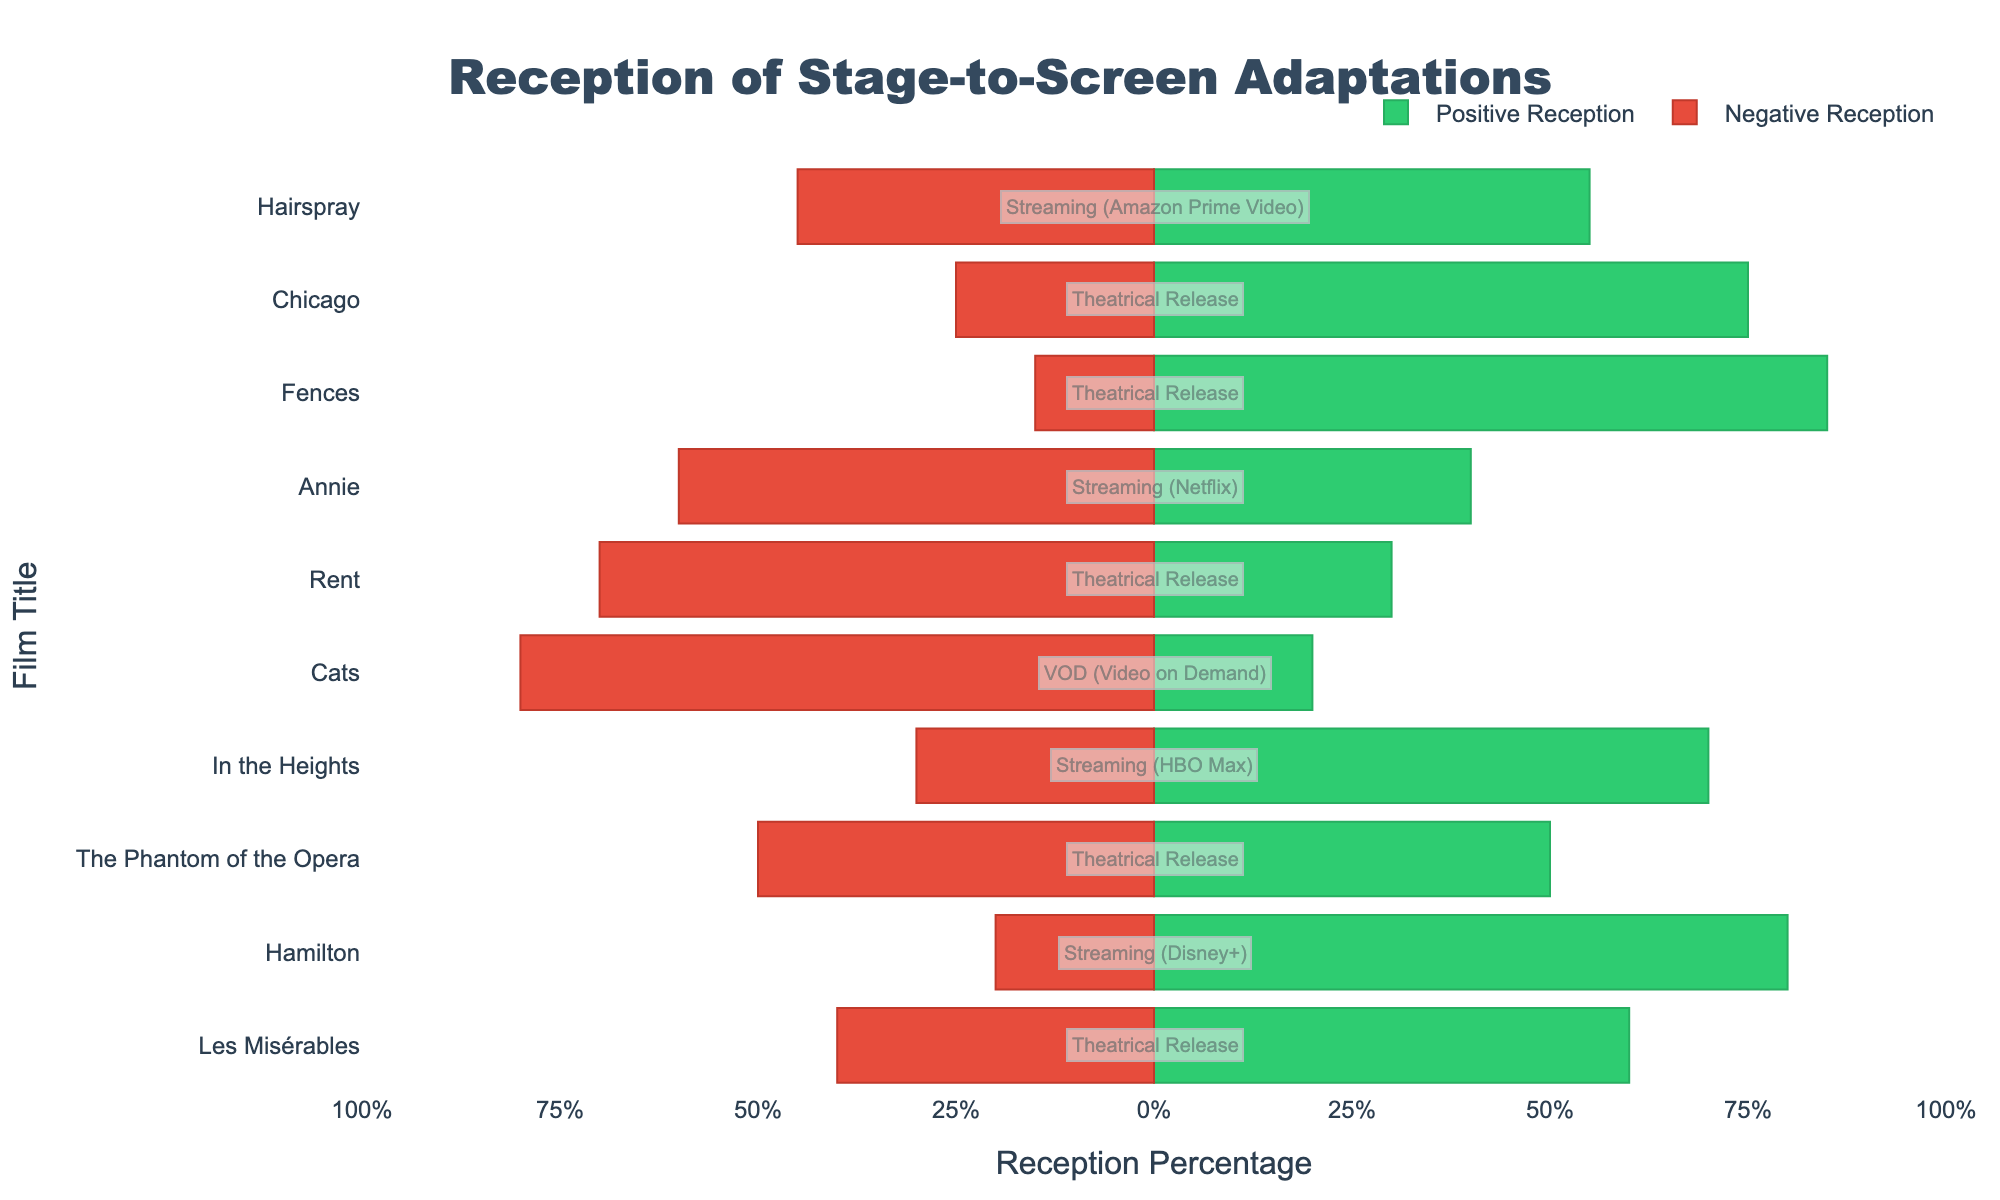Which film has the highest percentage of positive reception? Identify the bar with the highest value on the positive axis (green bars). Hamilton (80%) has the highest percentage of positive reception.
Answer: Hamilton Which film has the highest percentage of negative reception? Identify the bar with the highest value on the negative axis (red bars). Cats (80%) has the highest percentage of negative reception.
Answer: Cats How does the reception of "Les Misérables" compare to "Fences"? Compare the green and red bars for both films. "Les Misérables" has 60% positive and 40% negative. "Fences" has 85% positive and 15% negative. "Fences" has a higher positive reception (85% vs. 60%) and a lower negative reception (15% vs. 40%).
Answer: Fences has higher positive reception and lower negative reception than Les Misérables What is the total reception (sum of positive and negative) for "In the Heights"? Add the positive and negative percentages for "In the Heights": 70% + 30% = 100%.
Answer: 100% Which distribution channel has the most mixed reception (closest to 50/50 split)? Look for the bar with the closest split between green and red bars. "The Phantom of the Opera" (Theatrical Release) has a 50/50 split.
Answer: Theatrical Release What is the average positive reception for films released on streaming platforms? Calculate the average positive reception for Hamilton (80%), In the Heights (70%), Annie (40%), and Hairspray (55%). (80 + 70 + 40 + 55) / 4 = 61.25%.
Answer: 61.25% Which film has a higher percentage of positive reception, "Chicago" or "Hairspray"? Compare the green bars for both films. Chicago has 75% positive reception, while Hairspray has 55% positive reception.
Answer: Chicago How much greater is the positive reception percentage for "Fences" compared to "Rent"? Subtract Rent's positive reception (30%) from Fences' positive reception (85%). 85% - 30% = 55%.
Answer: 55% What percentage of films released on theatrical channels received positive reception? Identify the films released through theatrical channels: Les Misérables (60%), The Phantom of the Opera (50%), Rent (30%), Fences (85%), and Chicago (75%). Calculate the average: (60 + 50 + 30 + 85 + 75) / 5 = 60%.
Answer: 60% Which film on a VOD channel had the worst reception? Identify the film released on VOD: Cats, with 20% positive and 80% negative reception. It is the only VOD film and has a poor reception.
Answer: Cats 